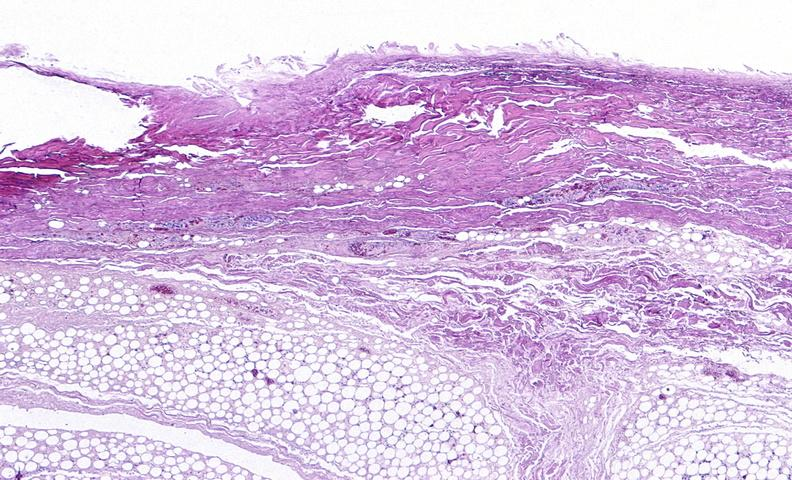what does this image show?
Answer the question using a single word or phrase. Panniculitis and fascitis 